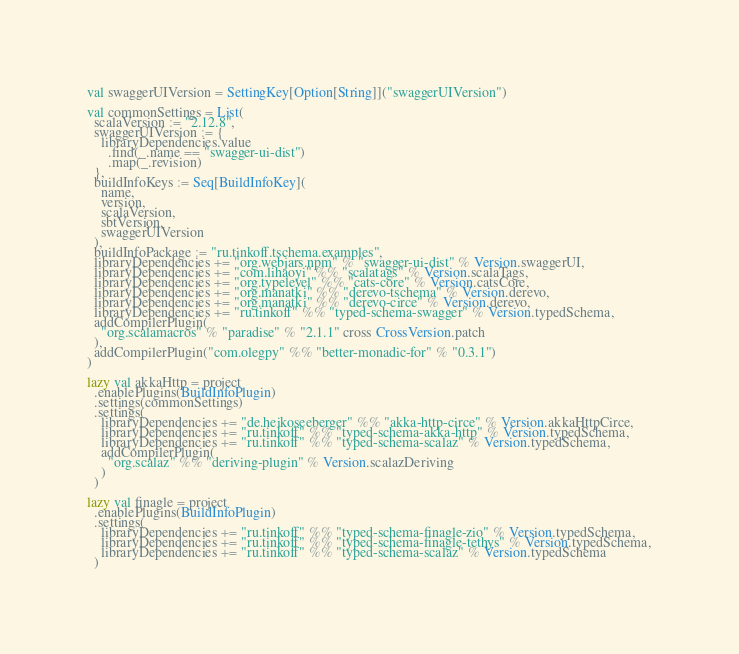Convert code to text. <code><loc_0><loc_0><loc_500><loc_500><_Scala_>val swaggerUIVersion = SettingKey[Option[String]]("swaggerUIVersion")

val commonSettings = List(
  scalaVersion := "2.12.8",
  swaggerUIVersion := {
    libraryDependencies.value
      .find(_.name == "swagger-ui-dist")
      .map(_.revision)
  },
  buildInfoKeys := Seq[BuildInfoKey](
    name,
    version,
    scalaVersion,
    sbtVersion,
    swaggerUIVersion
  ),
  buildInfoPackage := "ru.tinkoff.tschema.examples",
  libraryDependencies += "org.webjars.npm" % "swagger-ui-dist" % Version.swaggerUI,
  libraryDependencies += "com.lihaoyi" %% "scalatags" % Version.scalaTags,
  libraryDependencies += "org.typelevel" %% "cats-core" % Version.catsCore,
  libraryDependencies += "org.manatki" %% "derevo-tschema" % Version.derevo,
  libraryDependencies += "org.manatki" %% "derevo-circe" % Version.derevo,
  libraryDependencies += "ru.tinkoff" %% "typed-schema-swagger" % Version.typedSchema,
  addCompilerPlugin(
    "org.scalamacros" % "paradise" % "2.1.1" cross CrossVersion.patch
  ),
  addCompilerPlugin("com.olegpy" %% "better-monadic-for" % "0.3.1")
)

lazy val akkaHttp = project
  .enablePlugins(BuildInfoPlugin)
  .settings(commonSettings)
  .settings(
    libraryDependencies += "de.heikoseeberger" %% "akka-http-circe" % Version.akkaHttpCirce,
    libraryDependencies += "ru.tinkoff" %% "typed-schema-akka-http" % Version.typedSchema,
    libraryDependencies += "ru.tinkoff" %% "typed-schema-scalaz" % Version.typedSchema,
    addCompilerPlugin(
      "org.scalaz" %% "deriving-plugin" % Version.scalazDeriving
    )
  )

lazy val finagle = project
  .enablePlugins(BuildInfoPlugin)
  .settings(
    libraryDependencies += "ru.tinkoff" %% "typed-schema-finagle-zio" % Version.typedSchema,
    libraryDependencies += "ru.tinkoff" %% "typed-schema-finagle-tethys" % Version.typedSchema,
    libraryDependencies += "ru.tinkoff" %% "typed-schema-scalaz" % Version.typedSchema
  )
</code> 